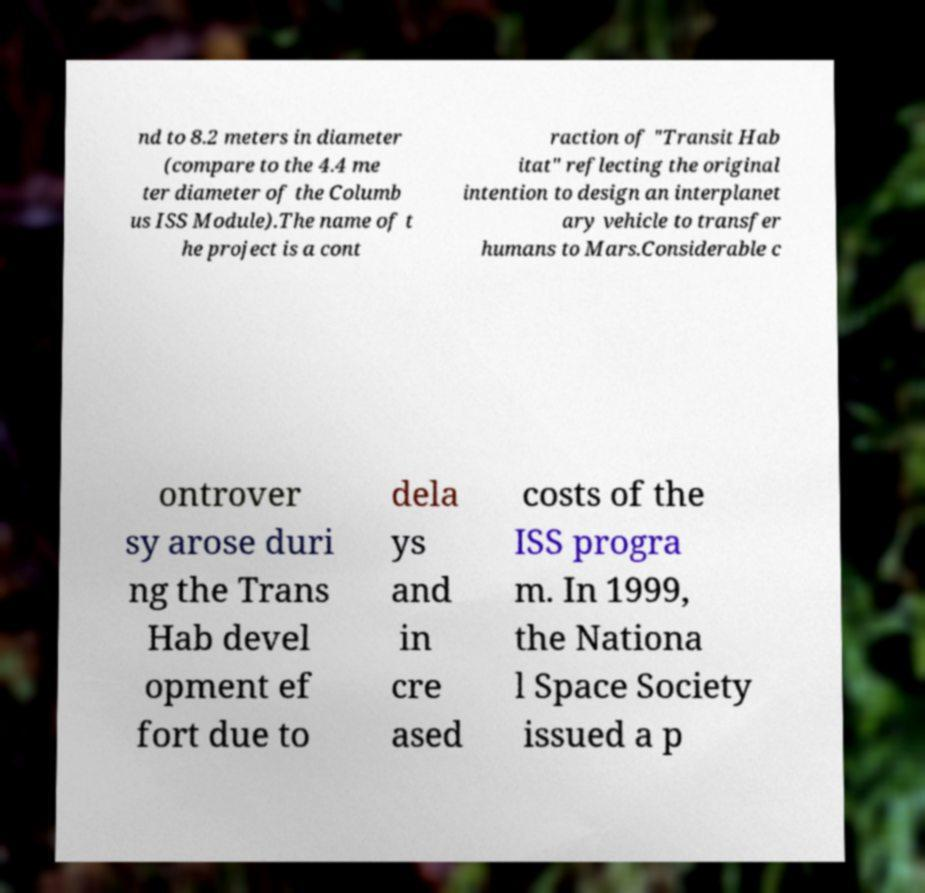Please identify and transcribe the text found in this image. nd to 8.2 meters in diameter (compare to the 4.4 me ter diameter of the Columb us ISS Module).The name of t he project is a cont raction of "Transit Hab itat" reflecting the original intention to design an interplanet ary vehicle to transfer humans to Mars.Considerable c ontrover sy arose duri ng the Trans Hab devel opment ef fort due to dela ys and in cre ased costs of the ISS progra m. In 1999, the Nationa l Space Society issued a p 